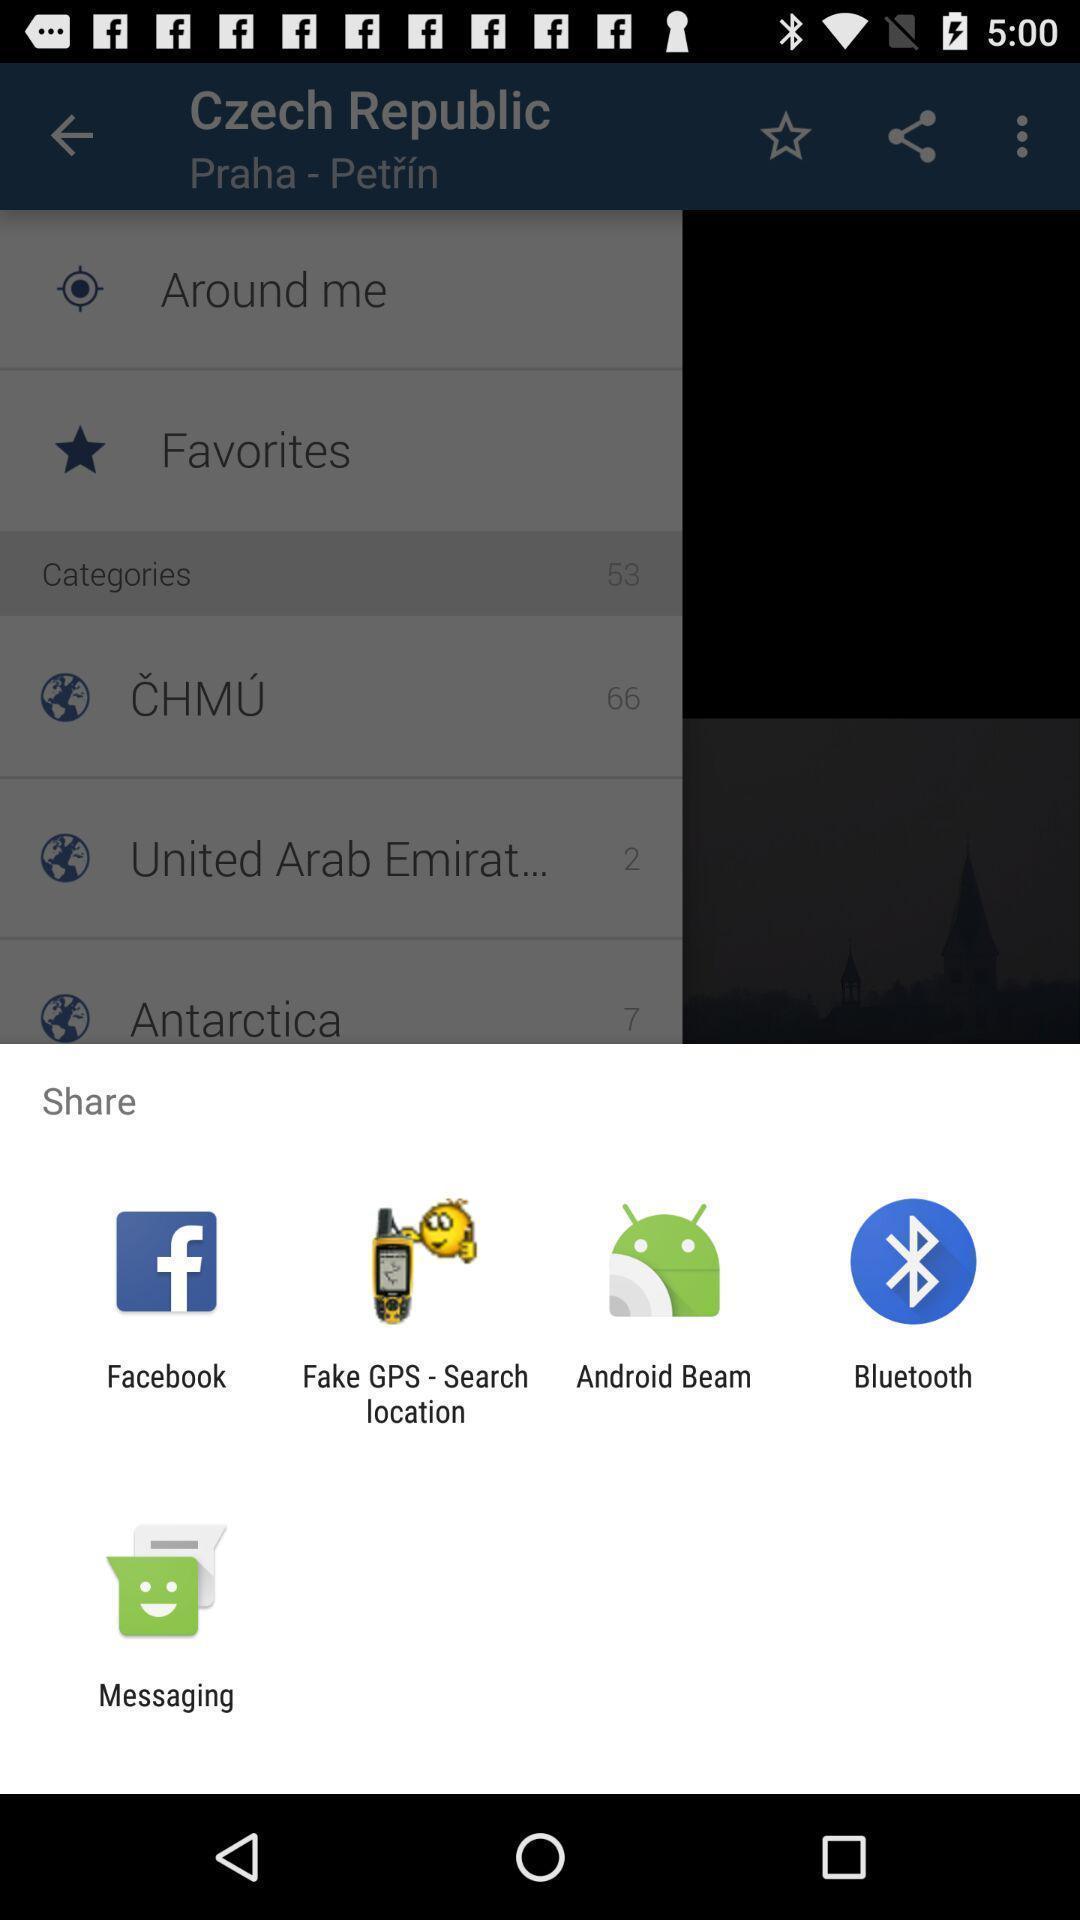Tell me about the visual elements in this screen capture. Push up displaying multiple applications to share. 